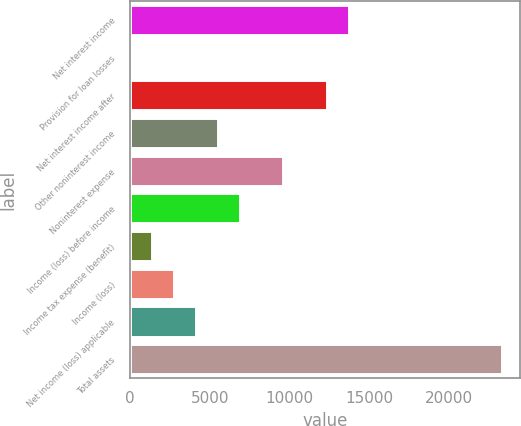Convert chart to OTSL. <chart><loc_0><loc_0><loc_500><loc_500><bar_chart><fcel>Net interest income<fcel>Provision for loan losses<fcel>Net interest income after<fcel>Other noninterest income<fcel>Noninterest expense<fcel>Income (loss) before income<fcel>Income tax expense (benefit)<fcel>Income (loss)<fcel>Net income (loss) applicable<fcel>Total assets<nl><fcel>13705<fcel>4.2<fcel>12334.9<fcel>5484.52<fcel>9594.76<fcel>6854.6<fcel>1374.28<fcel>2744.36<fcel>4114.44<fcel>23295.6<nl></chart> 